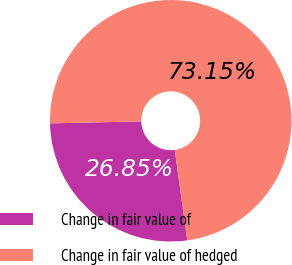<chart> <loc_0><loc_0><loc_500><loc_500><pie_chart><fcel>Change in fair value of<fcel>Change in fair value of hedged<nl><fcel>26.85%<fcel>73.15%<nl></chart> 